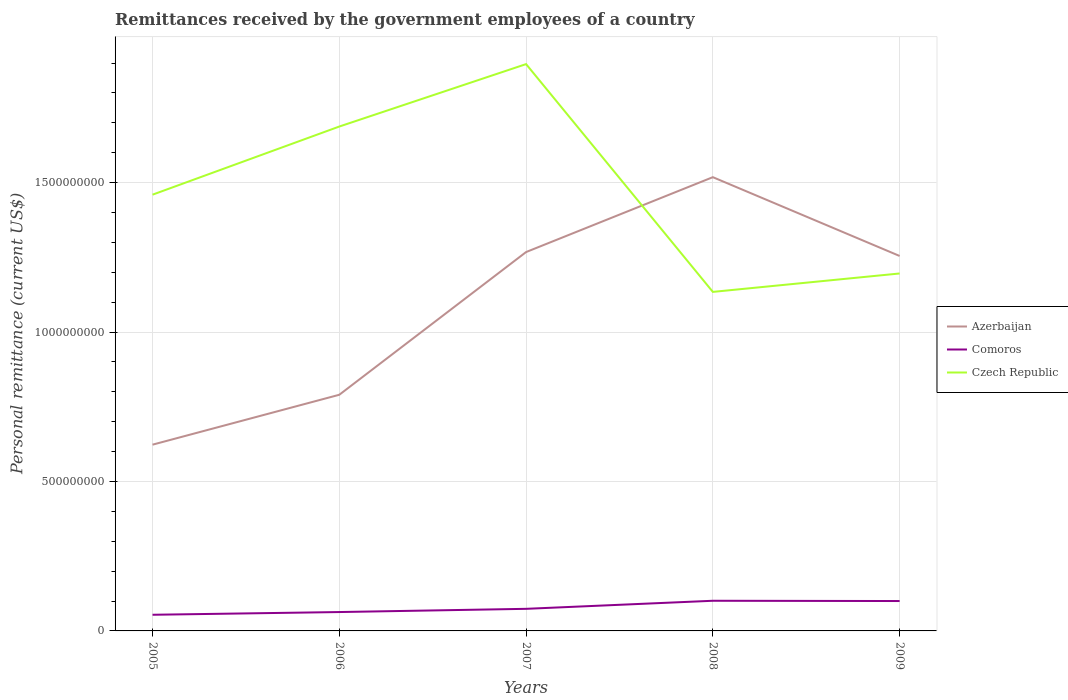How many different coloured lines are there?
Give a very brief answer. 3. Does the line corresponding to Czech Republic intersect with the line corresponding to Comoros?
Ensure brevity in your answer.  No. Is the number of lines equal to the number of legend labels?
Offer a terse response. Yes. Across all years, what is the maximum remittances received by the government employees in Czech Republic?
Make the answer very short. 1.13e+09. What is the total remittances received by the government employees in Comoros in the graph?
Your response must be concise. -2.61e+07. What is the difference between the highest and the second highest remittances received by the government employees in Czech Republic?
Give a very brief answer. 7.62e+08. What is the difference between the highest and the lowest remittances received by the government employees in Comoros?
Give a very brief answer. 2. How many lines are there?
Give a very brief answer. 3. Does the graph contain grids?
Make the answer very short. Yes. Where does the legend appear in the graph?
Your answer should be compact. Center right. How many legend labels are there?
Your answer should be very brief. 3. What is the title of the graph?
Ensure brevity in your answer.  Remittances received by the government employees of a country. Does "Serbia" appear as one of the legend labels in the graph?
Your answer should be compact. No. What is the label or title of the X-axis?
Your answer should be compact. Years. What is the label or title of the Y-axis?
Provide a short and direct response. Personal remittance (current US$). What is the Personal remittance (current US$) in Azerbaijan in 2005?
Your answer should be very brief. 6.23e+08. What is the Personal remittance (current US$) in Comoros in 2005?
Your answer should be very brief. 5.40e+07. What is the Personal remittance (current US$) in Czech Republic in 2005?
Offer a terse response. 1.46e+09. What is the Personal remittance (current US$) in Azerbaijan in 2006?
Your answer should be very brief. 7.90e+08. What is the Personal remittance (current US$) of Comoros in 2006?
Your answer should be very brief. 6.31e+07. What is the Personal remittance (current US$) in Czech Republic in 2006?
Make the answer very short. 1.69e+09. What is the Personal remittance (current US$) of Azerbaijan in 2007?
Provide a short and direct response. 1.27e+09. What is the Personal remittance (current US$) in Comoros in 2007?
Provide a succinct answer. 7.39e+07. What is the Personal remittance (current US$) in Czech Republic in 2007?
Give a very brief answer. 1.90e+09. What is the Personal remittance (current US$) in Azerbaijan in 2008?
Give a very brief answer. 1.52e+09. What is the Personal remittance (current US$) of Comoros in 2008?
Ensure brevity in your answer.  1.01e+08. What is the Personal remittance (current US$) in Czech Republic in 2008?
Give a very brief answer. 1.13e+09. What is the Personal remittance (current US$) of Azerbaijan in 2009?
Ensure brevity in your answer.  1.25e+09. What is the Personal remittance (current US$) of Comoros in 2009?
Provide a short and direct response. 1.00e+08. What is the Personal remittance (current US$) of Czech Republic in 2009?
Make the answer very short. 1.20e+09. Across all years, what is the maximum Personal remittance (current US$) of Azerbaijan?
Give a very brief answer. 1.52e+09. Across all years, what is the maximum Personal remittance (current US$) in Comoros?
Provide a succinct answer. 1.01e+08. Across all years, what is the maximum Personal remittance (current US$) of Czech Republic?
Ensure brevity in your answer.  1.90e+09. Across all years, what is the minimum Personal remittance (current US$) in Azerbaijan?
Ensure brevity in your answer.  6.23e+08. Across all years, what is the minimum Personal remittance (current US$) of Comoros?
Provide a short and direct response. 5.40e+07. Across all years, what is the minimum Personal remittance (current US$) of Czech Republic?
Your answer should be compact. 1.13e+09. What is the total Personal remittance (current US$) in Azerbaijan in the graph?
Make the answer very short. 5.45e+09. What is the total Personal remittance (current US$) in Comoros in the graph?
Provide a short and direct response. 3.92e+08. What is the total Personal remittance (current US$) of Czech Republic in the graph?
Your answer should be very brief. 7.37e+09. What is the difference between the Personal remittance (current US$) of Azerbaijan in 2005 and that in 2006?
Make the answer very short. -1.67e+08. What is the difference between the Personal remittance (current US$) in Comoros in 2005 and that in 2006?
Offer a very short reply. -9.11e+06. What is the difference between the Personal remittance (current US$) in Czech Republic in 2005 and that in 2006?
Offer a very short reply. -2.28e+08. What is the difference between the Personal remittance (current US$) of Azerbaijan in 2005 and that in 2007?
Make the answer very short. -6.44e+08. What is the difference between the Personal remittance (current US$) in Comoros in 2005 and that in 2007?
Offer a terse response. -1.99e+07. What is the difference between the Personal remittance (current US$) of Czech Republic in 2005 and that in 2007?
Your answer should be compact. -4.37e+08. What is the difference between the Personal remittance (current US$) in Azerbaijan in 2005 and that in 2008?
Your response must be concise. -8.95e+08. What is the difference between the Personal remittance (current US$) of Comoros in 2005 and that in 2008?
Give a very brief answer. -4.69e+07. What is the difference between the Personal remittance (current US$) in Czech Republic in 2005 and that in 2008?
Make the answer very short. 3.25e+08. What is the difference between the Personal remittance (current US$) in Azerbaijan in 2005 and that in 2009?
Provide a succinct answer. -6.31e+08. What is the difference between the Personal remittance (current US$) in Comoros in 2005 and that in 2009?
Ensure brevity in your answer.  -4.60e+07. What is the difference between the Personal remittance (current US$) in Czech Republic in 2005 and that in 2009?
Your answer should be very brief. 2.64e+08. What is the difference between the Personal remittance (current US$) in Azerbaijan in 2006 and that in 2007?
Provide a succinct answer. -4.78e+08. What is the difference between the Personal remittance (current US$) of Comoros in 2006 and that in 2007?
Provide a succinct answer. -1.08e+07. What is the difference between the Personal remittance (current US$) in Czech Republic in 2006 and that in 2007?
Your response must be concise. -2.09e+08. What is the difference between the Personal remittance (current US$) of Azerbaijan in 2006 and that in 2008?
Keep it short and to the point. -7.28e+08. What is the difference between the Personal remittance (current US$) in Comoros in 2006 and that in 2008?
Your answer should be very brief. -3.78e+07. What is the difference between the Personal remittance (current US$) of Czech Republic in 2006 and that in 2008?
Offer a terse response. 5.53e+08. What is the difference between the Personal remittance (current US$) in Azerbaijan in 2006 and that in 2009?
Offer a terse response. -4.64e+08. What is the difference between the Personal remittance (current US$) in Comoros in 2006 and that in 2009?
Keep it short and to the point. -3.69e+07. What is the difference between the Personal remittance (current US$) in Czech Republic in 2006 and that in 2009?
Your answer should be compact. 4.92e+08. What is the difference between the Personal remittance (current US$) in Azerbaijan in 2007 and that in 2008?
Provide a succinct answer. -2.51e+08. What is the difference between the Personal remittance (current US$) of Comoros in 2007 and that in 2008?
Your answer should be very brief. -2.70e+07. What is the difference between the Personal remittance (current US$) in Czech Republic in 2007 and that in 2008?
Give a very brief answer. 7.62e+08. What is the difference between the Personal remittance (current US$) of Azerbaijan in 2007 and that in 2009?
Provide a succinct answer. 1.31e+07. What is the difference between the Personal remittance (current US$) of Comoros in 2007 and that in 2009?
Offer a terse response. -2.61e+07. What is the difference between the Personal remittance (current US$) of Czech Republic in 2007 and that in 2009?
Your answer should be very brief. 7.01e+08. What is the difference between the Personal remittance (current US$) in Azerbaijan in 2008 and that in 2009?
Keep it short and to the point. 2.64e+08. What is the difference between the Personal remittance (current US$) in Comoros in 2008 and that in 2009?
Ensure brevity in your answer.  9.12e+05. What is the difference between the Personal remittance (current US$) in Czech Republic in 2008 and that in 2009?
Your answer should be compact. -6.16e+07. What is the difference between the Personal remittance (current US$) in Azerbaijan in 2005 and the Personal remittance (current US$) in Comoros in 2006?
Make the answer very short. 5.60e+08. What is the difference between the Personal remittance (current US$) of Azerbaijan in 2005 and the Personal remittance (current US$) of Czech Republic in 2006?
Make the answer very short. -1.06e+09. What is the difference between the Personal remittance (current US$) of Comoros in 2005 and the Personal remittance (current US$) of Czech Republic in 2006?
Keep it short and to the point. -1.63e+09. What is the difference between the Personal remittance (current US$) in Azerbaijan in 2005 and the Personal remittance (current US$) in Comoros in 2007?
Your answer should be compact. 5.49e+08. What is the difference between the Personal remittance (current US$) of Azerbaijan in 2005 and the Personal remittance (current US$) of Czech Republic in 2007?
Keep it short and to the point. -1.27e+09. What is the difference between the Personal remittance (current US$) in Comoros in 2005 and the Personal remittance (current US$) in Czech Republic in 2007?
Your answer should be compact. -1.84e+09. What is the difference between the Personal remittance (current US$) of Azerbaijan in 2005 and the Personal remittance (current US$) of Comoros in 2008?
Offer a terse response. 5.22e+08. What is the difference between the Personal remittance (current US$) in Azerbaijan in 2005 and the Personal remittance (current US$) in Czech Republic in 2008?
Your response must be concise. -5.11e+08. What is the difference between the Personal remittance (current US$) in Comoros in 2005 and the Personal remittance (current US$) in Czech Republic in 2008?
Your answer should be very brief. -1.08e+09. What is the difference between the Personal remittance (current US$) in Azerbaijan in 2005 and the Personal remittance (current US$) in Comoros in 2009?
Offer a very short reply. 5.23e+08. What is the difference between the Personal remittance (current US$) in Azerbaijan in 2005 and the Personal remittance (current US$) in Czech Republic in 2009?
Your answer should be compact. -5.73e+08. What is the difference between the Personal remittance (current US$) in Comoros in 2005 and the Personal remittance (current US$) in Czech Republic in 2009?
Ensure brevity in your answer.  -1.14e+09. What is the difference between the Personal remittance (current US$) in Azerbaijan in 2006 and the Personal remittance (current US$) in Comoros in 2007?
Your answer should be very brief. 7.16e+08. What is the difference between the Personal remittance (current US$) in Azerbaijan in 2006 and the Personal remittance (current US$) in Czech Republic in 2007?
Your answer should be compact. -1.11e+09. What is the difference between the Personal remittance (current US$) of Comoros in 2006 and the Personal remittance (current US$) of Czech Republic in 2007?
Your answer should be very brief. -1.83e+09. What is the difference between the Personal remittance (current US$) of Azerbaijan in 2006 and the Personal remittance (current US$) of Comoros in 2008?
Ensure brevity in your answer.  6.89e+08. What is the difference between the Personal remittance (current US$) in Azerbaijan in 2006 and the Personal remittance (current US$) in Czech Republic in 2008?
Provide a short and direct response. -3.44e+08. What is the difference between the Personal remittance (current US$) of Comoros in 2006 and the Personal remittance (current US$) of Czech Republic in 2008?
Your answer should be very brief. -1.07e+09. What is the difference between the Personal remittance (current US$) in Azerbaijan in 2006 and the Personal remittance (current US$) in Comoros in 2009?
Make the answer very short. 6.90e+08. What is the difference between the Personal remittance (current US$) in Azerbaijan in 2006 and the Personal remittance (current US$) in Czech Republic in 2009?
Offer a very short reply. -4.06e+08. What is the difference between the Personal remittance (current US$) in Comoros in 2006 and the Personal remittance (current US$) in Czech Republic in 2009?
Ensure brevity in your answer.  -1.13e+09. What is the difference between the Personal remittance (current US$) in Azerbaijan in 2007 and the Personal remittance (current US$) in Comoros in 2008?
Provide a short and direct response. 1.17e+09. What is the difference between the Personal remittance (current US$) in Azerbaijan in 2007 and the Personal remittance (current US$) in Czech Republic in 2008?
Make the answer very short. 1.33e+08. What is the difference between the Personal remittance (current US$) in Comoros in 2007 and the Personal remittance (current US$) in Czech Republic in 2008?
Your answer should be very brief. -1.06e+09. What is the difference between the Personal remittance (current US$) in Azerbaijan in 2007 and the Personal remittance (current US$) in Comoros in 2009?
Provide a short and direct response. 1.17e+09. What is the difference between the Personal remittance (current US$) of Azerbaijan in 2007 and the Personal remittance (current US$) of Czech Republic in 2009?
Provide a succinct answer. 7.17e+07. What is the difference between the Personal remittance (current US$) in Comoros in 2007 and the Personal remittance (current US$) in Czech Republic in 2009?
Offer a terse response. -1.12e+09. What is the difference between the Personal remittance (current US$) in Azerbaijan in 2008 and the Personal remittance (current US$) in Comoros in 2009?
Offer a terse response. 1.42e+09. What is the difference between the Personal remittance (current US$) of Azerbaijan in 2008 and the Personal remittance (current US$) of Czech Republic in 2009?
Your answer should be very brief. 3.22e+08. What is the difference between the Personal remittance (current US$) in Comoros in 2008 and the Personal remittance (current US$) in Czech Republic in 2009?
Keep it short and to the point. -1.10e+09. What is the average Personal remittance (current US$) of Azerbaijan per year?
Make the answer very short. 1.09e+09. What is the average Personal remittance (current US$) of Comoros per year?
Provide a short and direct response. 7.84e+07. What is the average Personal remittance (current US$) of Czech Republic per year?
Your answer should be compact. 1.47e+09. In the year 2005, what is the difference between the Personal remittance (current US$) of Azerbaijan and Personal remittance (current US$) of Comoros?
Give a very brief answer. 5.69e+08. In the year 2005, what is the difference between the Personal remittance (current US$) of Azerbaijan and Personal remittance (current US$) of Czech Republic?
Provide a succinct answer. -8.37e+08. In the year 2005, what is the difference between the Personal remittance (current US$) in Comoros and Personal remittance (current US$) in Czech Republic?
Give a very brief answer. -1.41e+09. In the year 2006, what is the difference between the Personal remittance (current US$) of Azerbaijan and Personal remittance (current US$) of Comoros?
Give a very brief answer. 7.27e+08. In the year 2006, what is the difference between the Personal remittance (current US$) in Azerbaijan and Personal remittance (current US$) in Czech Republic?
Give a very brief answer. -8.98e+08. In the year 2006, what is the difference between the Personal remittance (current US$) of Comoros and Personal remittance (current US$) of Czech Republic?
Your answer should be very brief. -1.62e+09. In the year 2007, what is the difference between the Personal remittance (current US$) of Azerbaijan and Personal remittance (current US$) of Comoros?
Make the answer very short. 1.19e+09. In the year 2007, what is the difference between the Personal remittance (current US$) in Azerbaijan and Personal remittance (current US$) in Czech Republic?
Make the answer very short. -6.29e+08. In the year 2007, what is the difference between the Personal remittance (current US$) in Comoros and Personal remittance (current US$) in Czech Republic?
Provide a short and direct response. -1.82e+09. In the year 2008, what is the difference between the Personal remittance (current US$) in Azerbaijan and Personal remittance (current US$) in Comoros?
Your response must be concise. 1.42e+09. In the year 2008, what is the difference between the Personal remittance (current US$) of Azerbaijan and Personal remittance (current US$) of Czech Republic?
Give a very brief answer. 3.84e+08. In the year 2008, what is the difference between the Personal remittance (current US$) in Comoros and Personal remittance (current US$) in Czech Republic?
Ensure brevity in your answer.  -1.03e+09. In the year 2009, what is the difference between the Personal remittance (current US$) in Azerbaijan and Personal remittance (current US$) in Comoros?
Your response must be concise. 1.15e+09. In the year 2009, what is the difference between the Personal remittance (current US$) in Azerbaijan and Personal remittance (current US$) in Czech Republic?
Offer a very short reply. 5.86e+07. In the year 2009, what is the difference between the Personal remittance (current US$) of Comoros and Personal remittance (current US$) of Czech Republic?
Your answer should be compact. -1.10e+09. What is the ratio of the Personal remittance (current US$) in Azerbaijan in 2005 to that in 2006?
Provide a succinct answer. 0.79. What is the ratio of the Personal remittance (current US$) of Comoros in 2005 to that in 2006?
Your answer should be compact. 0.86. What is the ratio of the Personal remittance (current US$) in Czech Republic in 2005 to that in 2006?
Your response must be concise. 0.86. What is the ratio of the Personal remittance (current US$) of Azerbaijan in 2005 to that in 2007?
Provide a short and direct response. 0.49. What is the ratio of the Personal remittance (current US$) in Comoros in 2005 to that in 2007?
Your response must be concise. 0.73. What is the ratio of the Personal remittance (current US$) in Czech Republic in 2005 to that in 2007?
Provide a succinct answer. 0.77. What is the ratio of the Personal remittance (current US$) of Azerbaijan in 2005 to that in 2008?
Your response must be concise. 0.41. What is the ratio of the Personal remittance (current US$) of Comoros in 2005 to that in 2008?
Offer a very short reply. 0.54. What is the ratio of the Personal remittance (current US$) of Czech Republic in 2005 to that in 2008?
Your answer should be compact. 1.29. What is the ratio of the Personal remittance (current US$) of Azerbaijan in 2005 to that in 2009?
Offer a very short reply. 0.5. What is the ratio of the Personal remittance (current US$) of Comoros in 2005 to that in 2009?
Make the answer very short. 0.54. What is the ratio of the Personal remittance (current US$) of Czech Republic in 2005 to that in 2009?
Provide a succinct answer. 1.22. What is the ratio of the Personal remittance (current US$) of Azerbaijan in 2006 to that in 2007?
Make the answer very short. 0.62. What is the ratio of the Personal remittance (current US$) of Comoros in 2006 to that in 2007?
Give a very brief answer. 0.85. What is the ratio of the Personal remittance (current US$) in Czech Republic in 2006 to that in 2007?
Your response must be concise. 0.89. What is the ratio of the Personal remittance (current US$) in Azerbaijan in 2006 to that in 2008?
Provide a short and direct response. 0.52. What is the ratio of the Personal remittance (current US$) of Comoros in 2006 to that in 2008?
Give a very brief answer. 0.63. What is the ratio of the Personal remittance (current US$) in Czech Republic in 2006 to that in 2008?
Your answer should be compact. 1.49. What is the ratio of the Personal remittance (current US$) in Azerbaijan in 2006 to that in 2009?
Your response must be concise. 0.63. What is the ratio of the Personal remittance (current US$) of Comoros in 2006 to that in 2009?
Your response must be concise. 0.63. What is the ratio of the Personal remittance (current US$) in Czech Republic in 2006 to that in 2009?
Provide a short and direct response. 1.41. What is the ratio of the Personal remittance (current US$) of Azerbaijan in 2007 to that in 2008?
Your answer should be compact. 0.83. What is the ratio of the Personal remittance (current US$) in Comoros in 2007 to that in 2008?
Your response must be concise. 0.73. What is the ratio of the Personal remittance (current US$) of Czech Republic in 2007 to that in 2008?
Keep it short and to the point. 1.67. What is the ratio of the Personal remittance (current US$) of Azerbaijan in 2007 to that in 2009?
Give a very brief answer. 1.01. What is the ratio of the Personal remittance (current US$) in Comoros in 2007 to that in 2009?
Your answer should be compact. 0.74. What is the ratio of the Personal remittance (current US$) of Czech Republic in 2007 to that in 2009?
Provide a succinct answer. 1.59. What is the ratio of the Personal remittance (current US$) of Azerbaijan in 2008 to that in 2009?
Give a very brief answer. 1.21. What is the ratio of the Personal remittance (current US$) of Comoros in 2008 to that in 2009?
Offer a terse response. 1.01. What is the ratio of the Personal remittance (current US$) of Czech Republic in 2008 to that in 2009?
Your answer should be compact. 0.95. What is the difference between the highest and the second highest Personal remittance (current US$) of Azerbaijan?
Your answer should be compact. 2.51e+08. What is the difference between the highest and the second highest Personal remittance (current US$) of Comoros?
Ensure brevity in your answer.  9.12e+05. What is the difference between the highest and the second highest Personal remittance (current US$) of Czech Republic?
Offer a terse response. 2.09e+08. What is the difference between the highest and the lowest Personal remittance (current US$) in Azerbaijan?
Give a very brief answer. 8.95e+08. What is the difference between the highest and the lowest Personal remittance (current US$) in Comoros?
Provide a short and direct response. 4.69e+07. What is the difference between the highest and the lowest Personal remittance (current US$) of Czech Republic?
Offer a very short reply. 7.62e+08. 